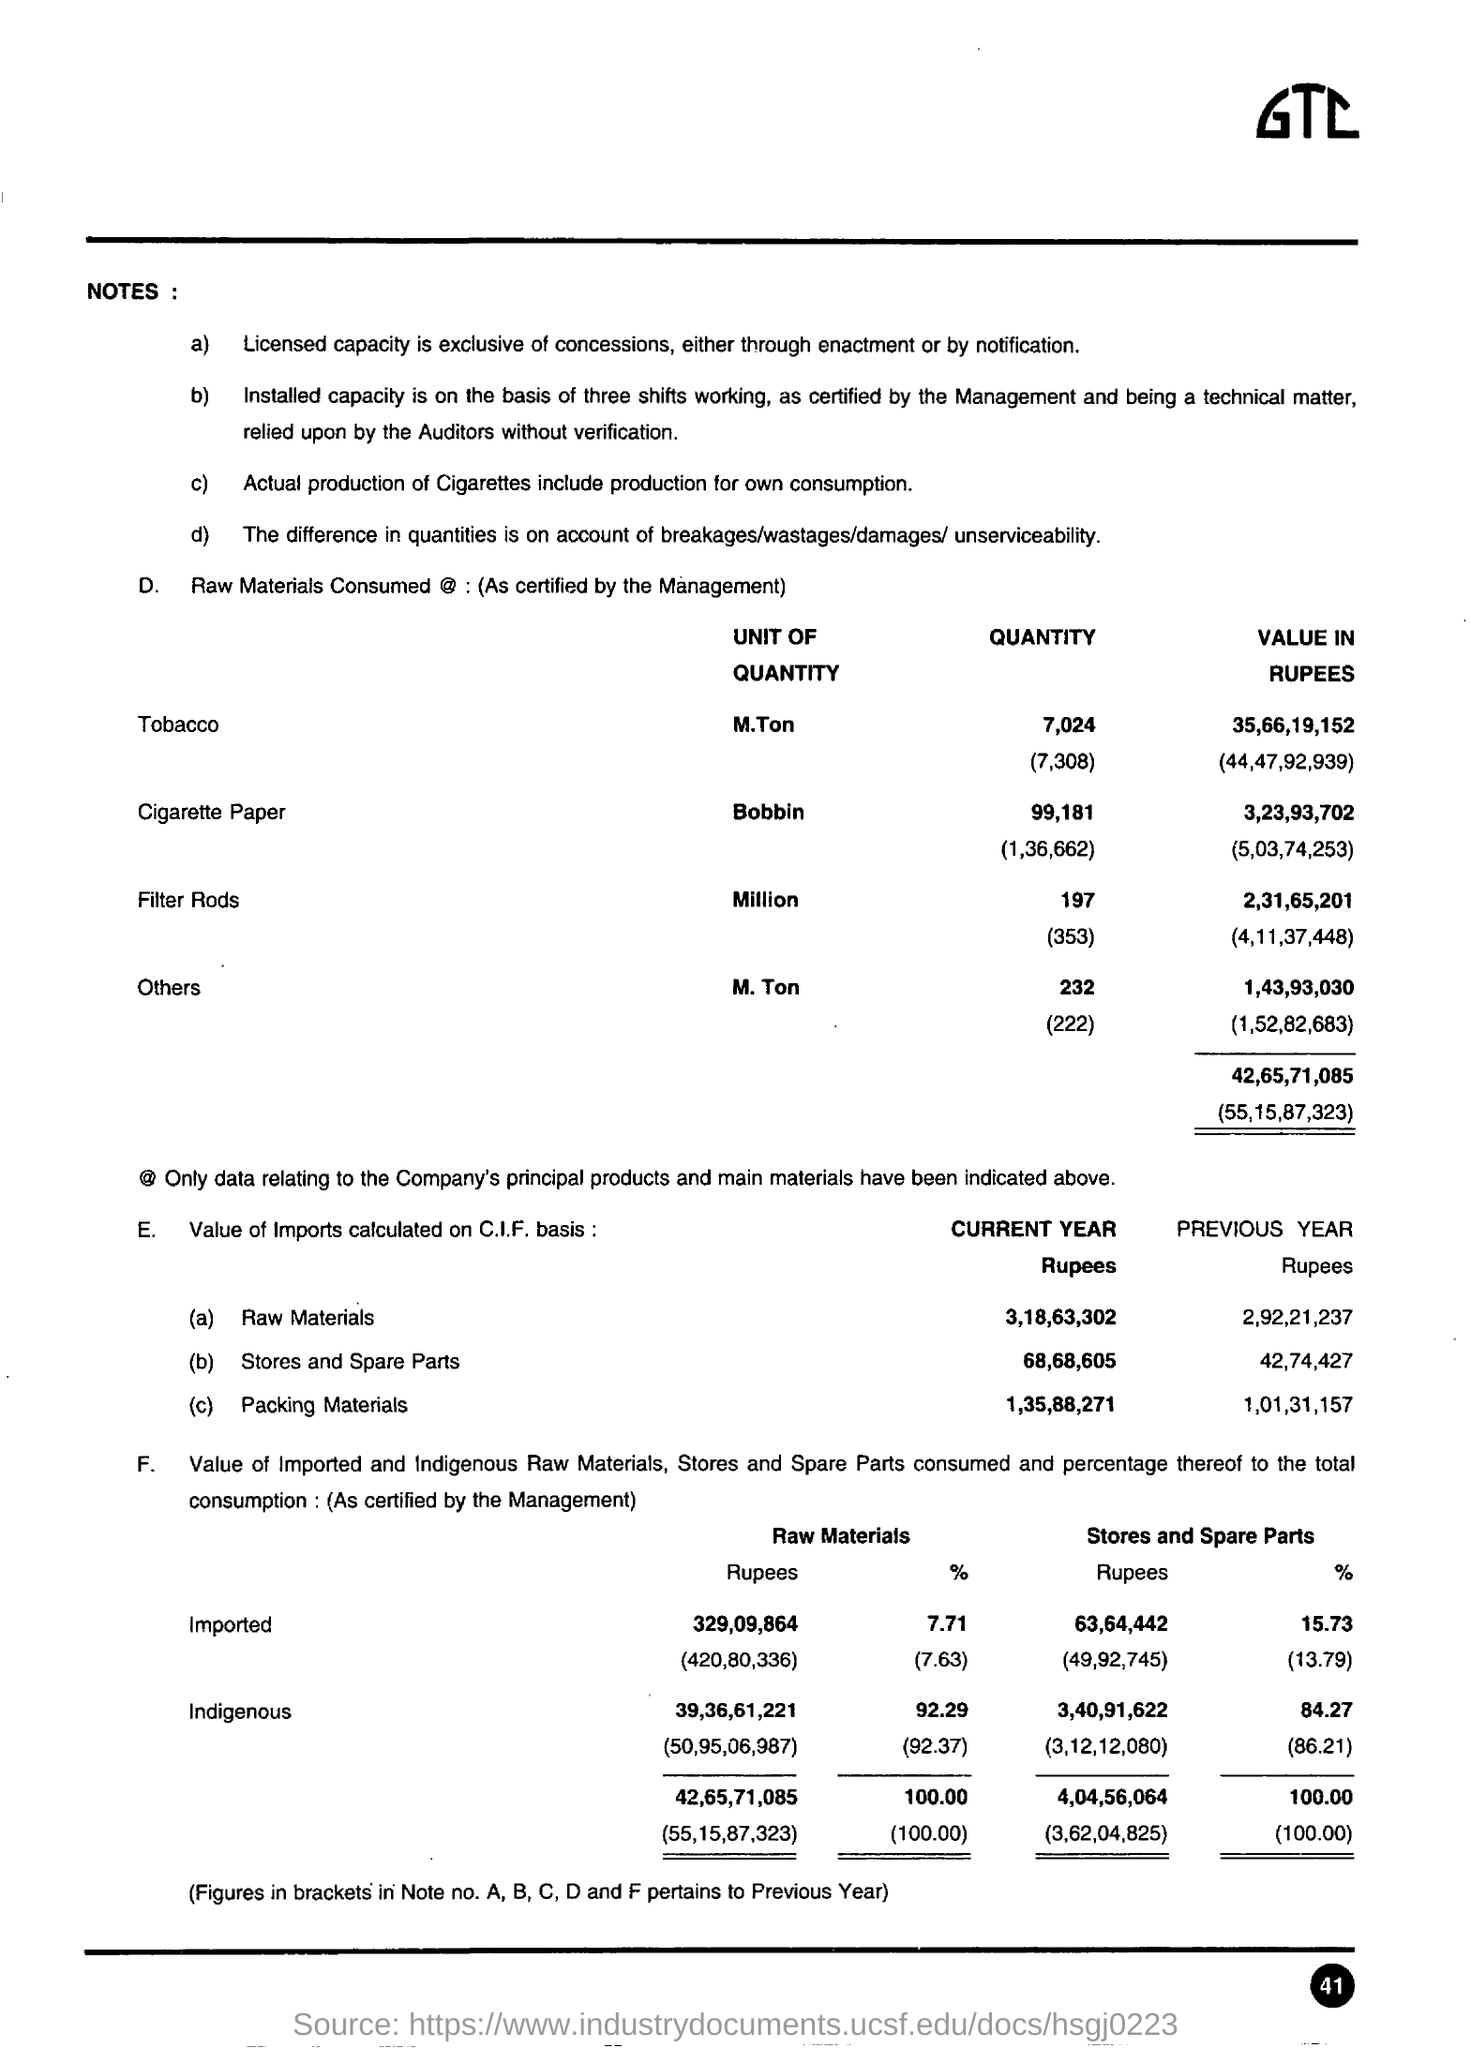What is the unit of quantity for cigarette paper ?
Ensure brevity in your answer.  Bobbin. What is the percentage value of indigenous raw materials in the previous year ?
Make the answer very short. (92.37). What is the percentage value of indigenous stores and spare parts in the previous year ?
Offer a very short reply. 86.21%. 